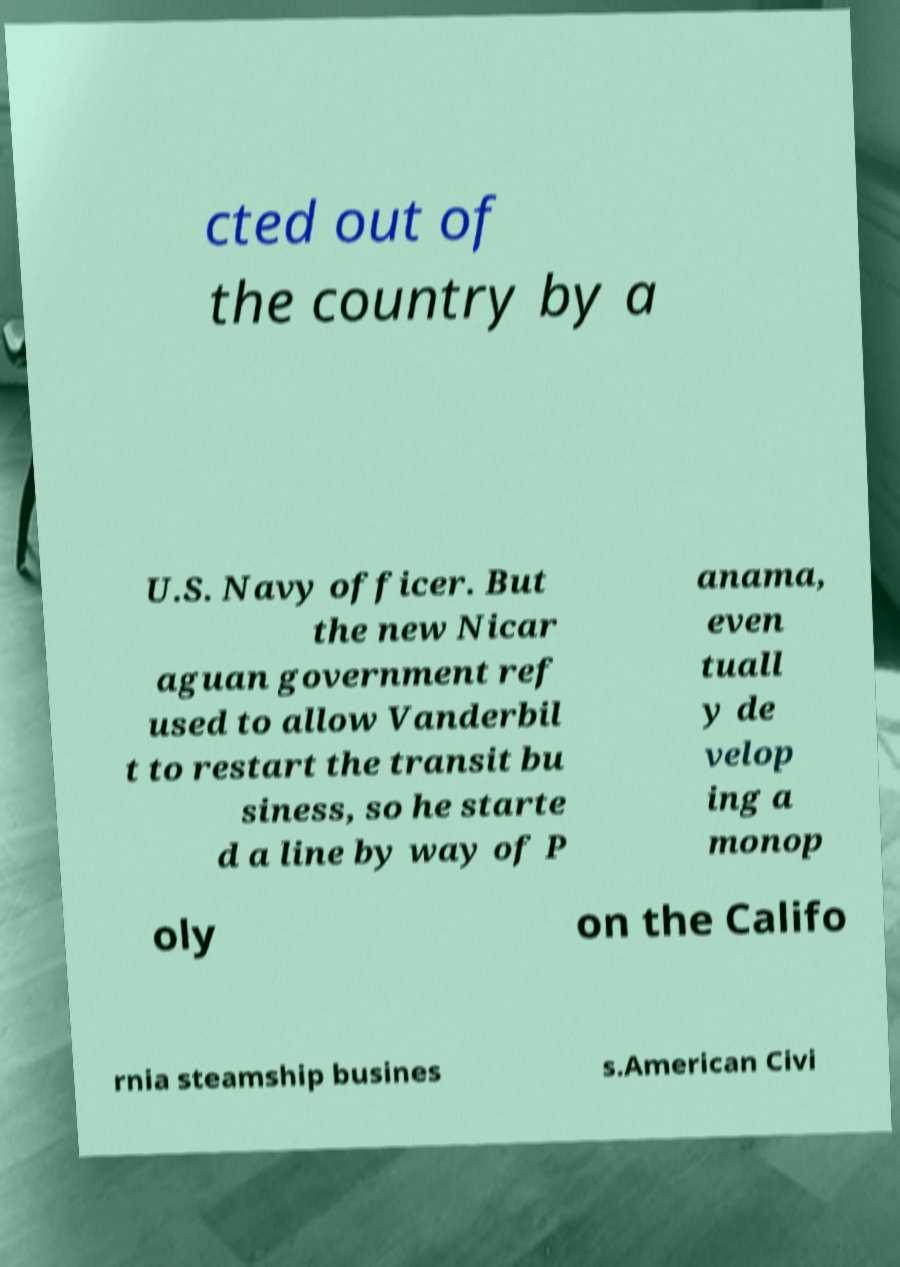For documentation purposes, I need the text within this image transcribed. Could you provide that? cted out of the country by a U.S. Navy officer. But the new Nicar aguan government ref used to allow Vanderbil t to restart the transit bu siness, so he starte d a line by way of P anama, even tuall y de velop ing a monop oly on the Califo rnia steamship busines s.American Civi 